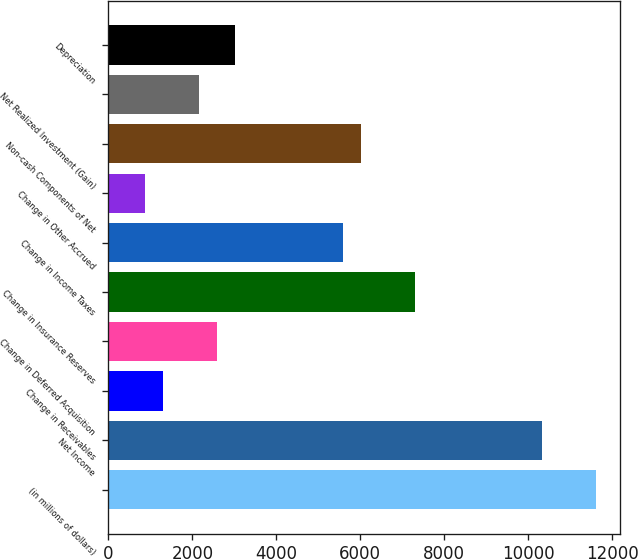<chart> <loc_0><loc_0><loc_500><loc_500><bar_chart><fcel>(in millions of dollars)<fcel>Net Income<fcel>Change in Receivables<fcel>Change in Deferred Acquisition<fcel>Change in Insurance Reserves<fcel>Change in Income Taxes<fcel>Change in Other Accrued<fcel>Non-cash Components of Net<fcel>Net Realized Investment (Gain)<fcel>Depreciation<nl><fcel>11613.4<fcel>10323.8<fcel>1296.07<fcel>2585.74<fcel>7314.53<fcel>5594.97<fcel>866.18<fcel>6024.86<fcel>2155.85<fcel>3015.63<nl></chart> 